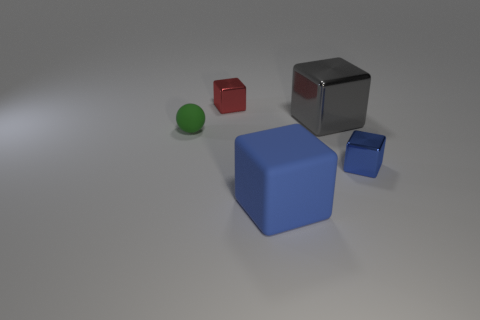There is a small thing that is to the left of the tiny blue metallic object and on the right side of the tiny green rubber ball; what material is it made of?
Ensure brevity in your answer.  Metal. What is the tiny thing behind the small matte thing made of?
Your answer should be very brief. Metal. There is another tiny thing that is made of the same material as the tiny red object; what is its color?
Your answer should be compact. Blue. There is a big gray metal thing; is its shape the same as the tiny metallic object behind the tiny green rubber sphere?
Ensure brevity in your answer.  Yes. Are there any blue objects to the left of the gray shiny object?
Your answer should be compact. Yes. There is a block that is the same color as the large matte object; what is its material?
Your answer should be compact. Metal. There is a red shiny thing; does it have the same size as the metallic thing that is in front of the big gray shiny thing?
Your response must be concise. Yes. Are there any other matte things of the same color as the small matte thing?
Offer a terse response. No. Are there any large red objects that have the same shape as the gray metal object?
Offer a terse response. No. The small thing that is both in front of the tiny red metallic block and to the left of the gray cube has what shape?
Ensure brevity in your answer.  Sphere. 